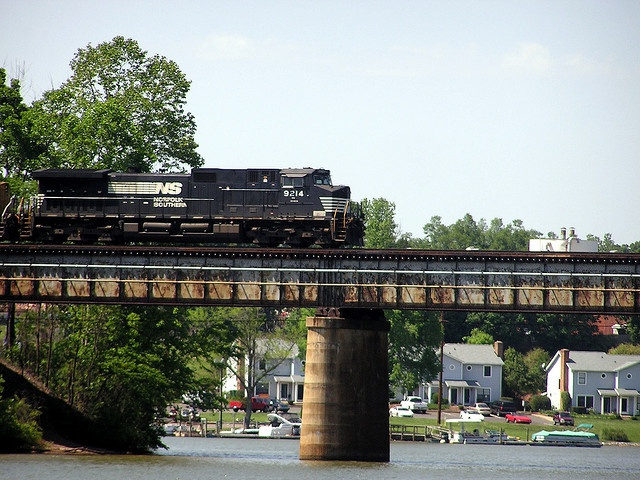Describe the objects in this image and their specific colors. I can see train in lavender, black, gray, and ivory tones, boat in lavender, gray, olive, white, and black tones, boat in lightgray, white, darkgray, gray, and black tones, boat in lavender, gray, ivory, and black tones, and truck in lightgray, black, maroon, gray, and darkgreen tones in this image. 